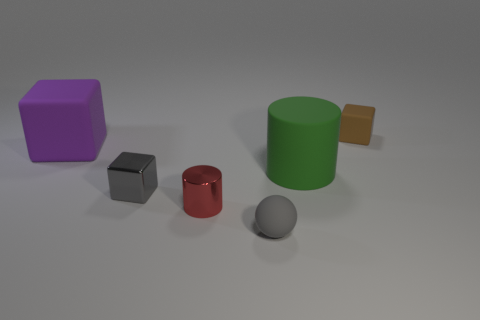There is a small cube left of the tiny matte cube; is its color the same as the small matte object that is in front of the large cube?
Your answer should be very brief. Yes. There is a red object that is the same size as the gray shiny block; what material is it?
Keep it short and to the point. Metal. Is there a gray cube of the same size as the metallic cylinder?
Ensure brevity in your answer.  Yes. Are there fewer tiny brown blocks that are left of the green cylinder than small shiny cylinders?
Give a very brief answer. Yes. Are there fewer gray matte spheres on the left side of the tiny red thing than green cylinders left of the big green rubber thing?
Offer a terse response. No. What number of balls are either red objects or big purple things?
Keep it short and to the point. 0. Do the cube that is in front of the big purple thing and the ball that is on the left side of the green rubber object have the same material?
Offer a terse response. No. The purple object that is the same size as the green rubber cylinder is what shape?
Make the answer very short. Cube. What number of other objects are there of the same color as the rubber sphere?
Your answer should be compact. 1. How many gray things are either tiny balls or cubes?
Your answer should be very brief. 2. 